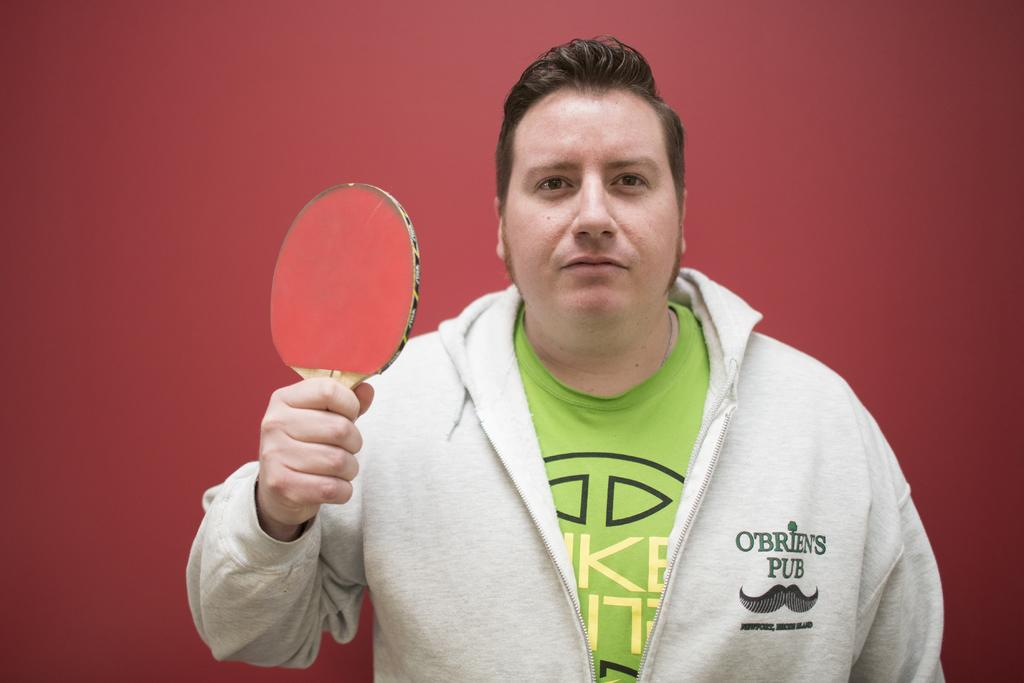Who is present in the image? There is a person in the image. What is the person wearing on their upper body? The person is wearing a white jacket and a green t-shirt. What object is the person holding in their hand? A: The person is holding a bat in their hand. What type of bag is the person carrying in the image? There is no bag visible in the image. 